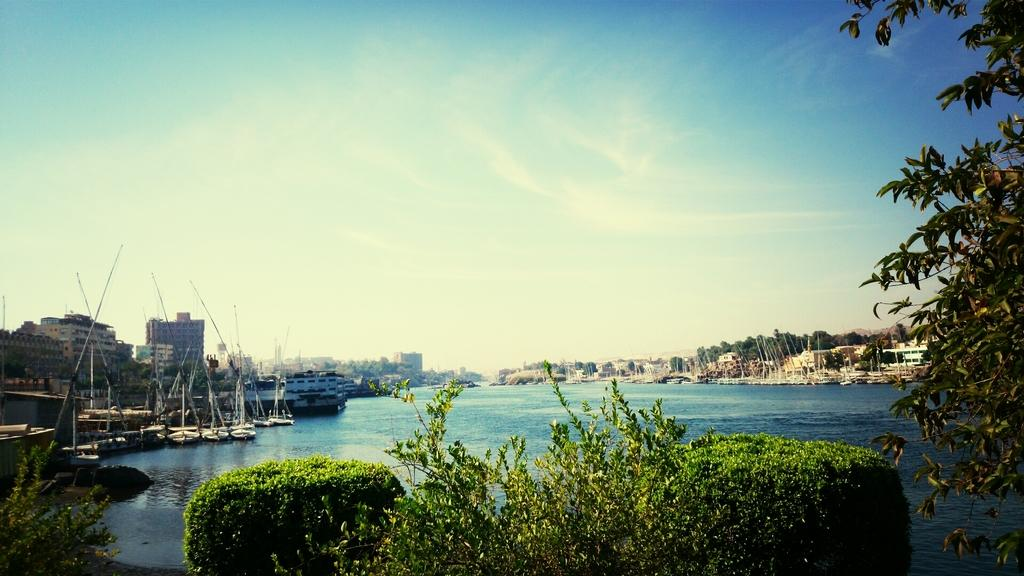What types of vegetation are at the bottom of the image? There are plants and trees at the bottom of the image. What can be seen on the water in the background? There are boats on the water in the background. What structures are visible in the background? There are buildings in the background. What else can be seen in the background besides buildings? There are trees in the background. What is the color of the sky in the image? The sky is blue in the image. What else can be seen in the sky? There are clouds in the blue sky. Can you tell me how many goldfish are swimming in the water in the image? There are no goldfish visible in the image; it features boats on the water. What type of poison is present in the image? There is no poison present in the image. 